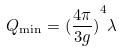<formula> <loc_0><loc_0><loc_500><loc_500>Q _ { \min } = { ( \frac { 4 \pi } { 3 g } ) } ^ { 4 } \lambda</formula> 